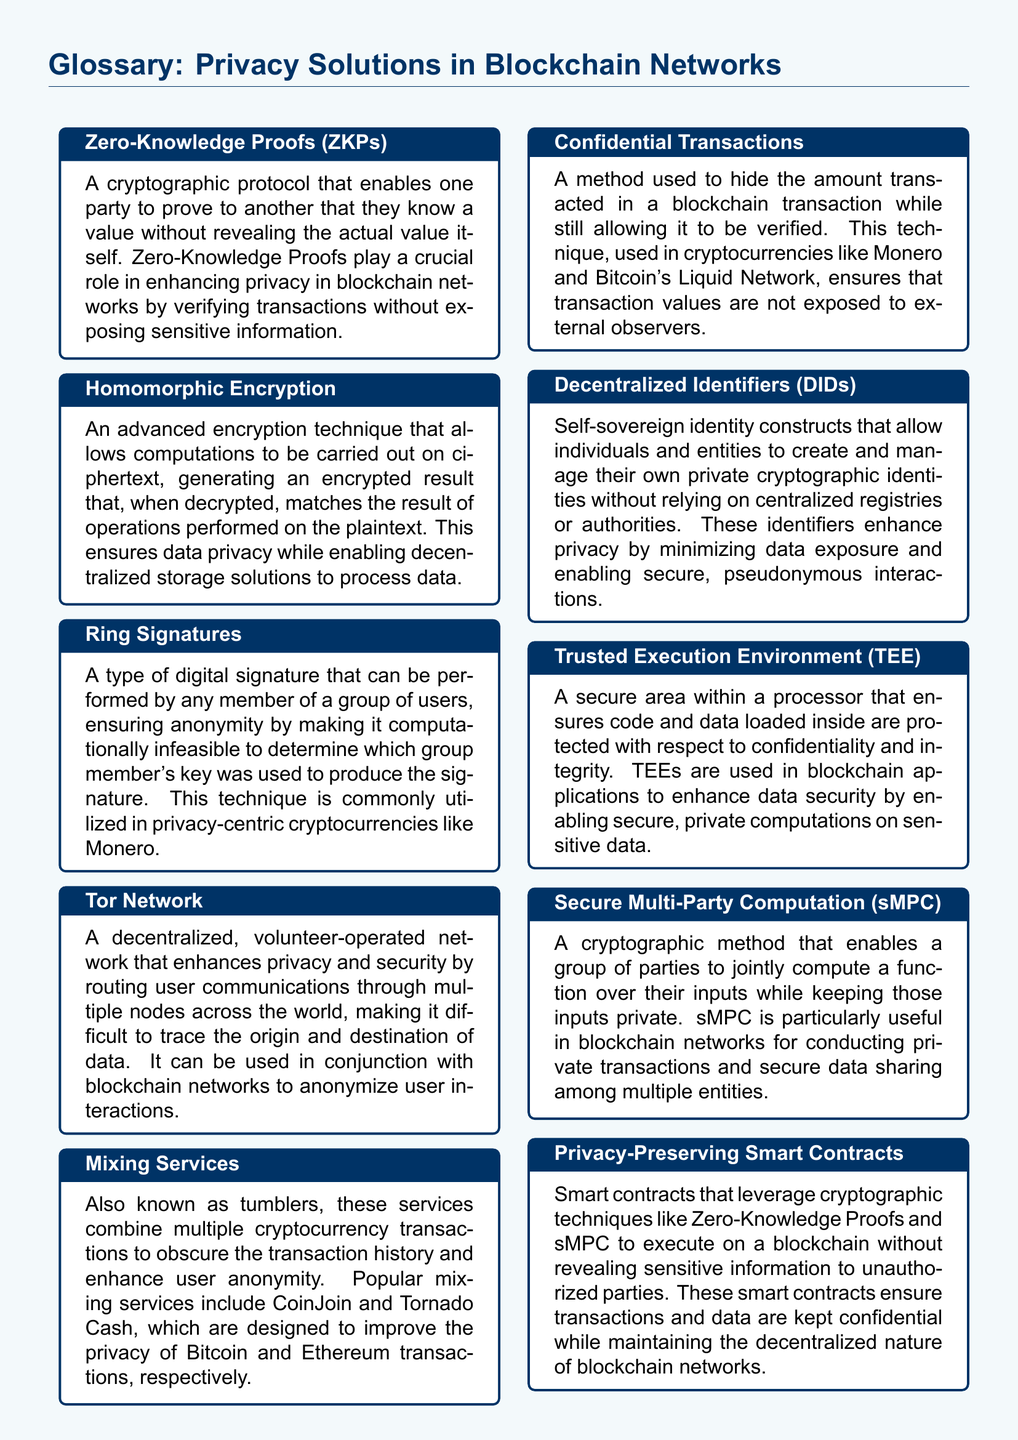What are Zero-Knowledge Proofs? Zero-Knowledge Proofs are defined in the document as a cryptographic protocol that enables one party to prove to another that they know a value without revealing the actual value itself.
Answer: A cryptographic protocol What is the role of Homomorphic Encryption? The document states that Homomorphic Encryption allows computations to be carried out on ciphertext, ensuring data privacy while enabling decentralized storage solutions to process data.
Answer: Ensures data privacy What is the function of Ring Signatures? Ring Signatures are described as a type of digital signature that ensures anonymity by making it computationally infeasible to determine which group member's key was used to produce the signature.
Answer: Ensures anonymity Which privacy solution uses a decentralized network to enhance user privacy? The document mentions the Tor Network, which is a decentralized, volunteer-operated network that enhances privacy and security by routing user communications through multiple nodes.
Answer: Tor Network What do Mixing Services accomplish? Mixing Services are defined as services that combine multiple cryptocurrency transactions to obscure the transaction history and enhance user anonymity.
Answer: Obscure transaction history What is the purpose of Confidential Transactions? The document states that Confidential Transactions are used to hide the amount transacted in a blockchain transaction while allowing it to be verified.
Answer: Hide transaction amount What are Decentralized Identifiers? Decentralized Identifiers are defined as self-sovereign identity constructs that allow individuals to create and manage their own private cryptographic identities.
Answer: Self-sovereign identity constructs What is a Trusted Execution Environment? A Trusted Execution Environment is described as a secure area within a processor that ensures code and data loaded inside are protected with respect to confidentiality and integrity.
Answer: Secure area within a processor Which cryptographic method enables a group to compute a function while keeping inputs private? The document describes Secure Multi-Party Computation as a cryptographic method that enables a group to jointly compute a function over their inputs while keeping those inputs private.
Answer: Secure Multi-Party Computation What do Privacy-Preserving Smart Contracts leverage? Privacy-Preserving Smart Contracts leverage cryptographic techniques like Zero-Knowledge Proofs and Secure Multi-Party Computation to execute on a blockchain.
Answer: Cryptographic techniques 